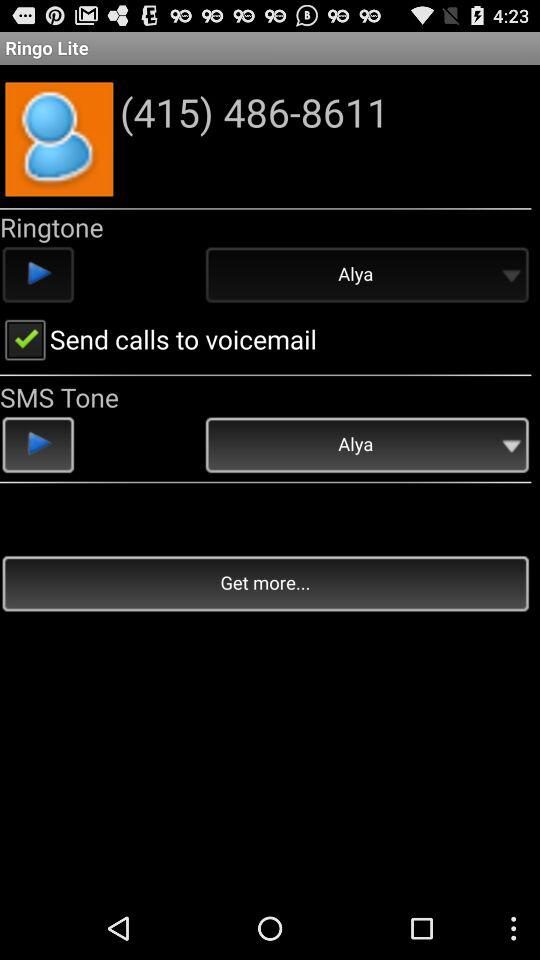What is the given phone number? The given phone number is (415) 486-8611. 